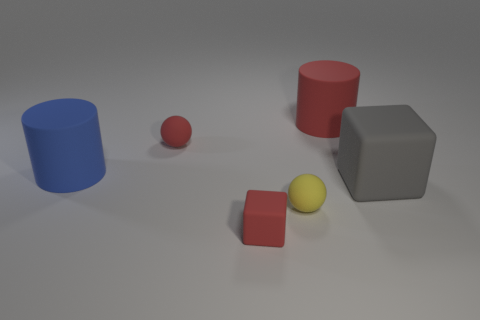Is there any other thing that is the same size as the yellow ball?
Your response must be concise. Yes. There is a red matte thing that is the same size as the red rubber cube; what is its shape?
Your response must be concise. Sphere. The big red matte thing is what shape?
Keep it short and to the point. Cylinder. Is the small red object that is behind the gray matte cube made of the same material as the big block?
Your answer should be very brief. Yes. What is the size of the sphere in front of the big rubber thing that is to the left of the red cylinder?
Your response must be concise. Small. What color is the small rubber thing that is in front of the big rubber block and left of the yellow rubber object?
Your response must be concise. Red. What is the material of the red cylinder that is the same size as the gray thing?
Provide a short and direct response. Rubber. How many other things are there of the same material as the small cube?
Ensure brevity in your answer.  5. Do the large cylinder behind the small red sphere and the cube left of the large red thing have the same color?
Your response must be concise. Yes. What is the shape of the small red matte object that is behind the rubber cube behind the small yellow rubber object?
Your response must be concise. Sphere. 